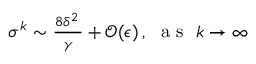Convert formula to latex. <formula><loc_0><loc_0><loc_500><loc_500>\begin{array} { r } { \sigma ^ { k } \sim \frac { 8 \delta ^ { 2 } \, } { \gamma } + \mathcal { O } ( \epsilon ) \, , a s k \rightarrow \infty } \end{array}</formula> 